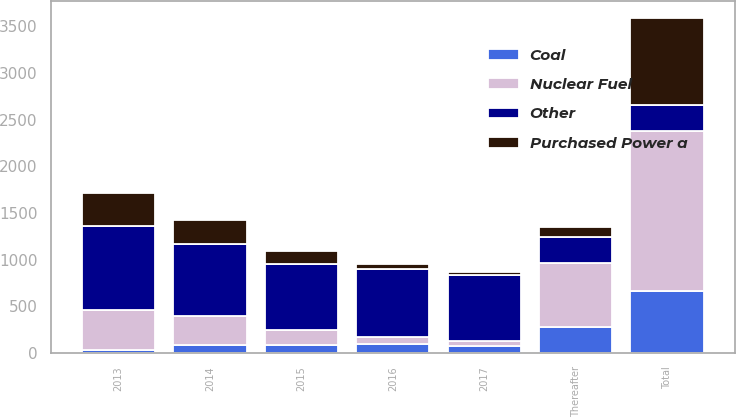Convert chart. <chart><loc_0><loc_0><loc_500><loc_500><stacked_bar_chart><ecel><fcel>2013<fcel>2014<fcel>2015<fcel>2016<fcel>2017<fcel>Thereafter<fcel>Total<nl><fcel>Other<fcel>908<fcel>774<fcel>702<fcel>732<fcel>701<fcel>277<fcel>277<nl><fcel>Purchased Power a<fcel>349<fcel>254<fcel>138<fcel>54<fcel>34<fcel>105<fcel>934<nl><fcel>Coal<fcel>36<fcel>89<fcel>87<fcel>95<fcel>78<fcel>277<fcel>662<nl><fcel>Nuclear Fuel<fcel>421<fcel>309<fcel>164<fcel>78<fcel>55<fcel>687<fcel>1714<nl></chart> 